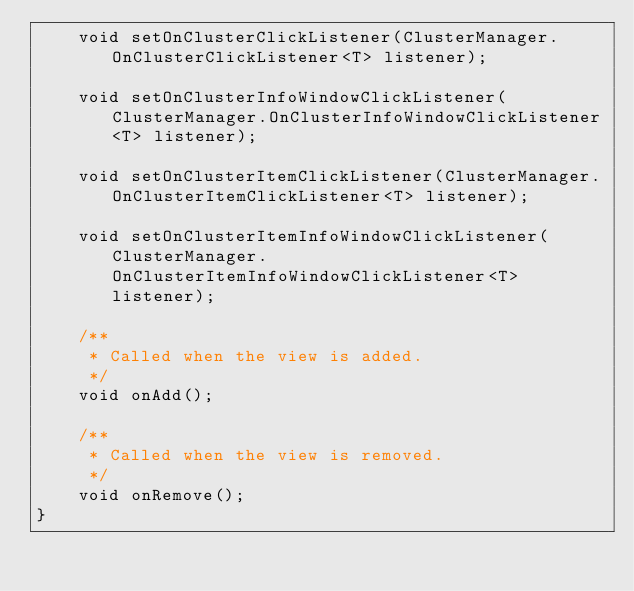<code> <loc_0><loc_0><loc_500><loc_500><_Java_>    void setOnClusterClickListener(ClusterManager.OnClusterClickListener<T> listener);

    void setOnClusterInfoWindowClickListener(ClusterManager.OnClusterInfoWindowClickListener<T> listener);

    void setOnClusterItemClickListener(ClusterManager.OnClusterItemClickListener<T> listener);

    void setOnClusterItemInfoWindowClickListener(ClusterManager.OnClusterItemInfoWindowClickListener<T> listener);

    /**
     * Called when the view is added.
     */
    void onAdd();

    /**
     * Called when the view is removed.
     */
    void onRemove();
}</code> 